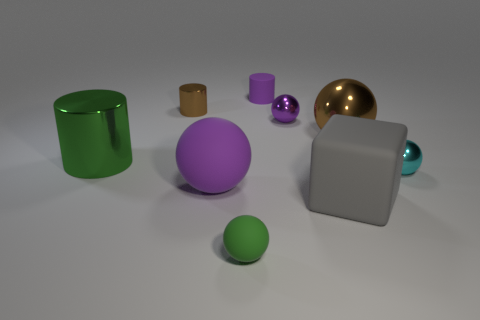Subtract all brown balls. How many balls are left? 4 Subtract 1 spheres. How many spheres are left? 4 Subtract all tiny green spheres. How many spheres are left? 4 Subtract all red spheres. Subtract all brown cylinders. How many spheres are left? 5 Add 1 cylinders. How many objects exist? 10 Subtract all cubes. How many objects are left? 8 Subtract 1 purple cylinders. How many objects are left? 8 Subtract all large green things. Subtract all tiny purple metal balls. How many objects are left? 7 Add 4 small green objects. How many small green objects are left? 5 Add 4 cylinders. How many cylinders exist? 7 